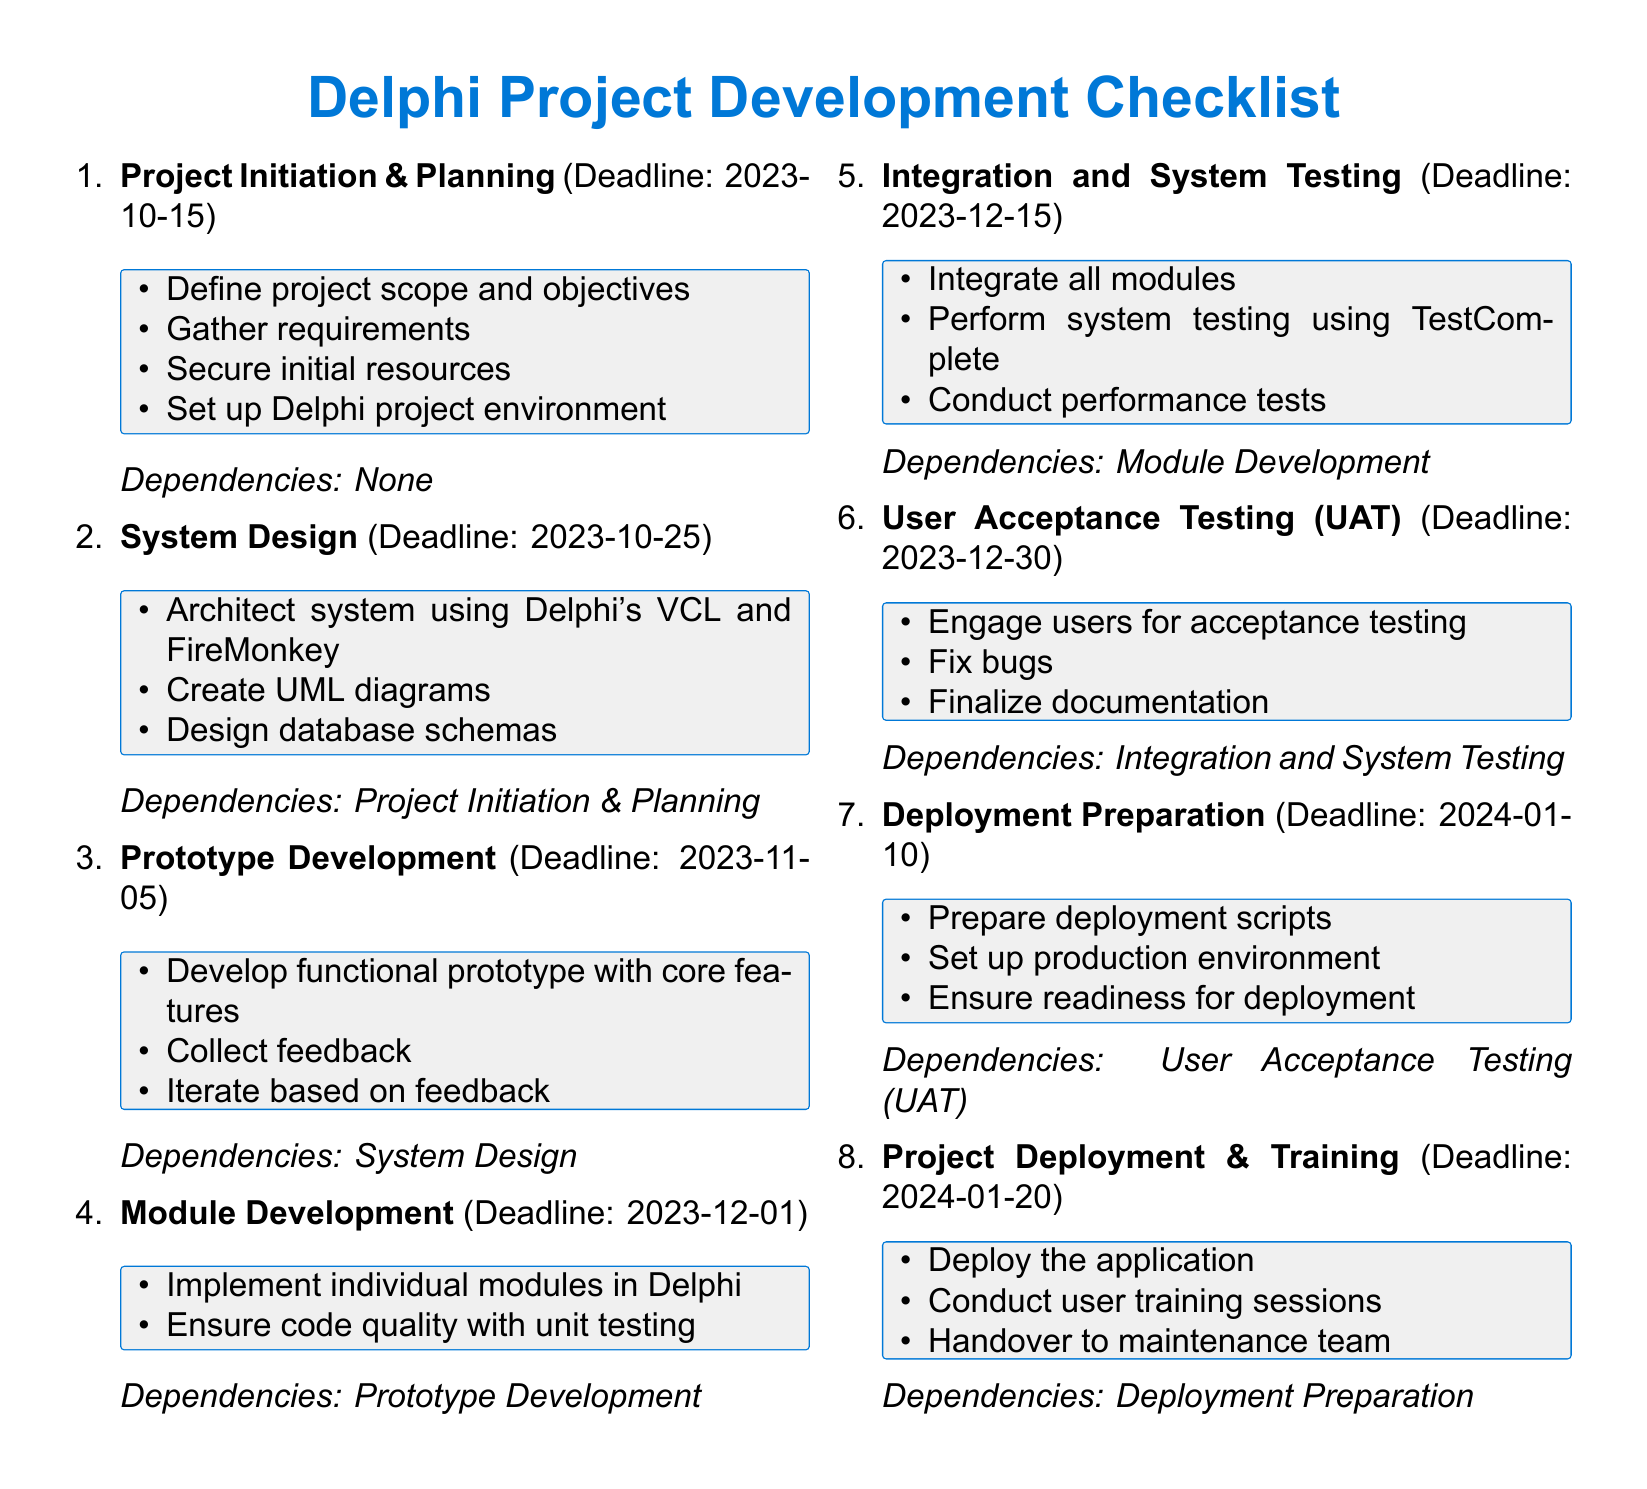What is the deadline for Project Initiation & Planning? The deadline for Project Initiation & Planning can be found in the milestone section of the document.
Answer: 2023-10-15 What is the last milestone listed in the document? The last milestone can be identified by looking at the end of the checklist.
Answer: Project Deployment & Training What dependencies are listed for Integration and System Testing? The dependencies for Integration and System Testing are located alongside that specific milestone in the document.
Answer: Module Development How many days are there between Prototype Development and Module Development? The days between the two milestones are calculated by examining the deadlines for both.
Answer: 26 days What key activities are required in the User Acceptance Testing milestone? The key activities for User Acceptance Testing are outlined in the specific tasks listed for that milestone.
Answer: Engage users for acceptance testing, fix bugs, finalize documentation What milestone follows System Design? This question focuses on identifying the order of milestones presented in the checklist.
Answer: Prototype Development Which tool is mentioned for system testing? The tool for system testing is specified in the related milestone in the document.
Answer: TestComplete When is the deadline for Deployment Preparation? The deadline for Deployment Preparation is stated directly in the milestone details.
Answer: 2024-01-10 